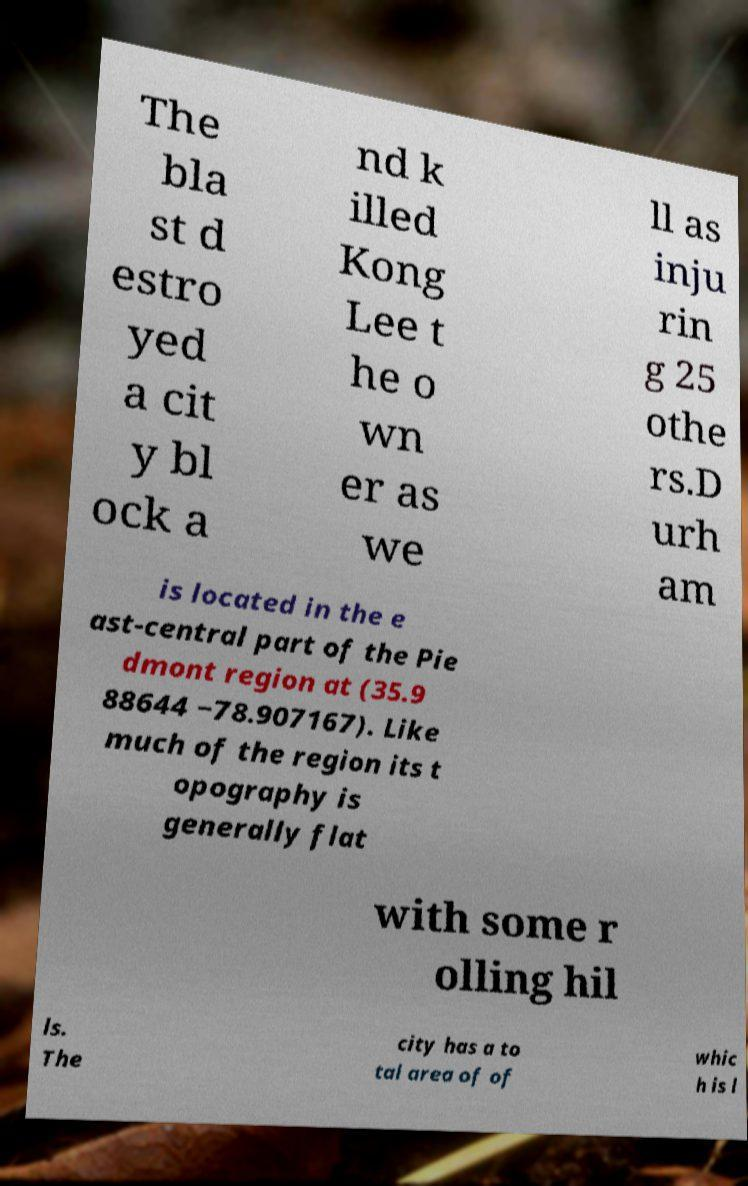I need the written content from this picture converted into text. Can you do that? The bla st d estro yed a cit y bl ock a nd k illed Kong Lee t he o wn er as we ll as inju rin g 25 othe rs.D urh am is located in the e ast-central part of the Pie dmont region at (35.9 88644 −78.907167). Like much of the region its t opography is generally flat with some r olling hil ls. The city has a to tal area of of whic h is l 